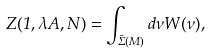<formula> <loc_0><loc_0><loc_500><loc_500>Z ( 1 , \lambda A , N ) = \int _ { \bar { \Sigma } ( M ) } d \nu W ( \nu ) ,</formula> 